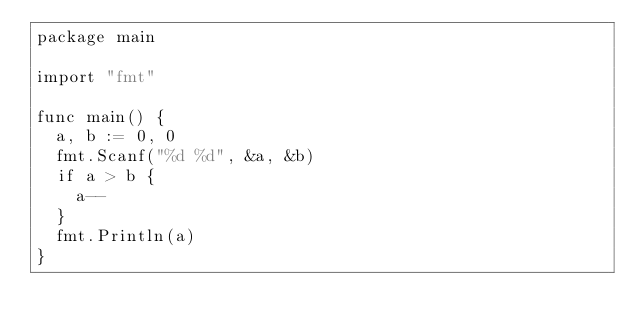<code> <loc_0><loc_0><loc_500><loc_500><_Go_>package main

import "fmt"

func main() {
	a, b := 0, 0
	fmt.Scanf("%d %d", &a, &b)
	if a > b {
		a--
	}
	fmt.Println(a)
}
</code> 